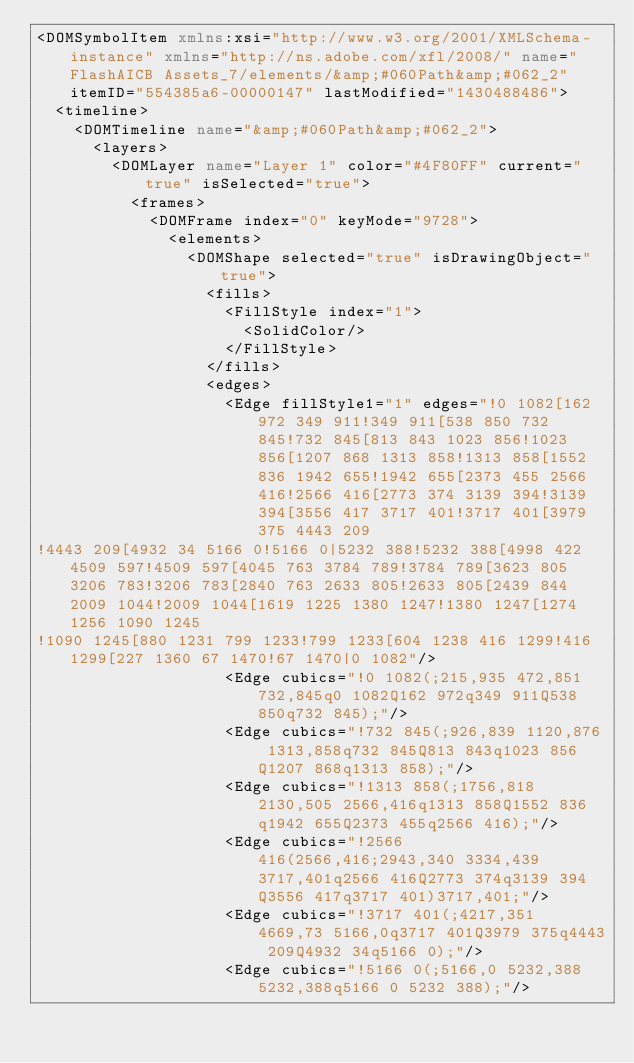Convert code to text. <code><loc_0><loc_0><loc_500><loc_500><_XML_><DOMSymbolItem xmlns:xsi="http://www.w3.org/2001/XMLSchema-instance" xmlns="http://ns.adobe.com/xfl/2008/" name="FlashAICB Assets_7/elements/&amp;#060Path&amp;#062_2" itemID="554385a6-00000147" lastModified="1430488486">
  <timeline>
    <DOMTimeline name="&amp;#060Path&amp;#062_2">
      <layers>
        <DOMLayer name="Layer 1" color="#4F80FF" current="true" isSelected="true">
          <frames>
            <DOMFrame index="0" keyMode="9728">
              <elements>
                <DOMShape selected="true" isDrawingObject="true">
                  <fills>
                    <FillStyle index="1">
                      <SolidColor/>
                    </FillStyle>
                  </fills>
                  <edges>
                    <Edge fillStyle1="1" edges="!0 1082[162 972 349 911!349 911[538 850 732 845!732 845[813 843 1023 856!1023 856[1207 868 1313 858!1313 858[1552 836 1942 655!1942 655[2373 455 2566 416!2566 416[2773 374 3139 394!3139 394[3556 417 3717 401!3717 401[3979 375 4443 209
!4443 209[4932 34 5166 0!5166 0|5232 388!5232 388[4998 422 4509 597!4509 597[4045 763 3784 789!3784 789[3623 805 3206 783!3206 783[2840 763 2633 805!2633 805[2439 844 2009 1044!2009 1044[1619 1225 1380 1247!1380 1247[1274 1256 1090 1245
!1090 1245[880 1231 799 1233!799 1233[604 1238 416 1299!416 1299[227 1360 67 1470!67 1470|0 1082"/>
                    <Edge cubics="!0 1082(;215,935 472,851 732,845q0 1082Q162 972q349 911Q538 850q732 845);"/>
                    <Edge cubics="!732 845(;926,839 1120,876 1313,858q732 845Q813 843q1023 856Q1207 868q1313 858);"/>
                    <Edge cubics="!1313 858(;1756,818 2130,505 2566,416q1313 858Q1552 836q1942 655Q2373 455q2566 416);"/>
                    <Edge cubics="!2566 416(2566,416;2943,340 3334,439 3717,401q2566 416Q2773 374q3139 394Q3556 417q3717 401)3717,401;"/>
                    <Edge cubics="!3717 401(;4217,351 4669,73 5166,0q3717 401Q3979 375q4443 209Q4932 34q5166 0);"/>
                    <Edge cubics="!5166 0(;5166,0 5232,388 5232,388q5166 0 5232 388);"/></code> 